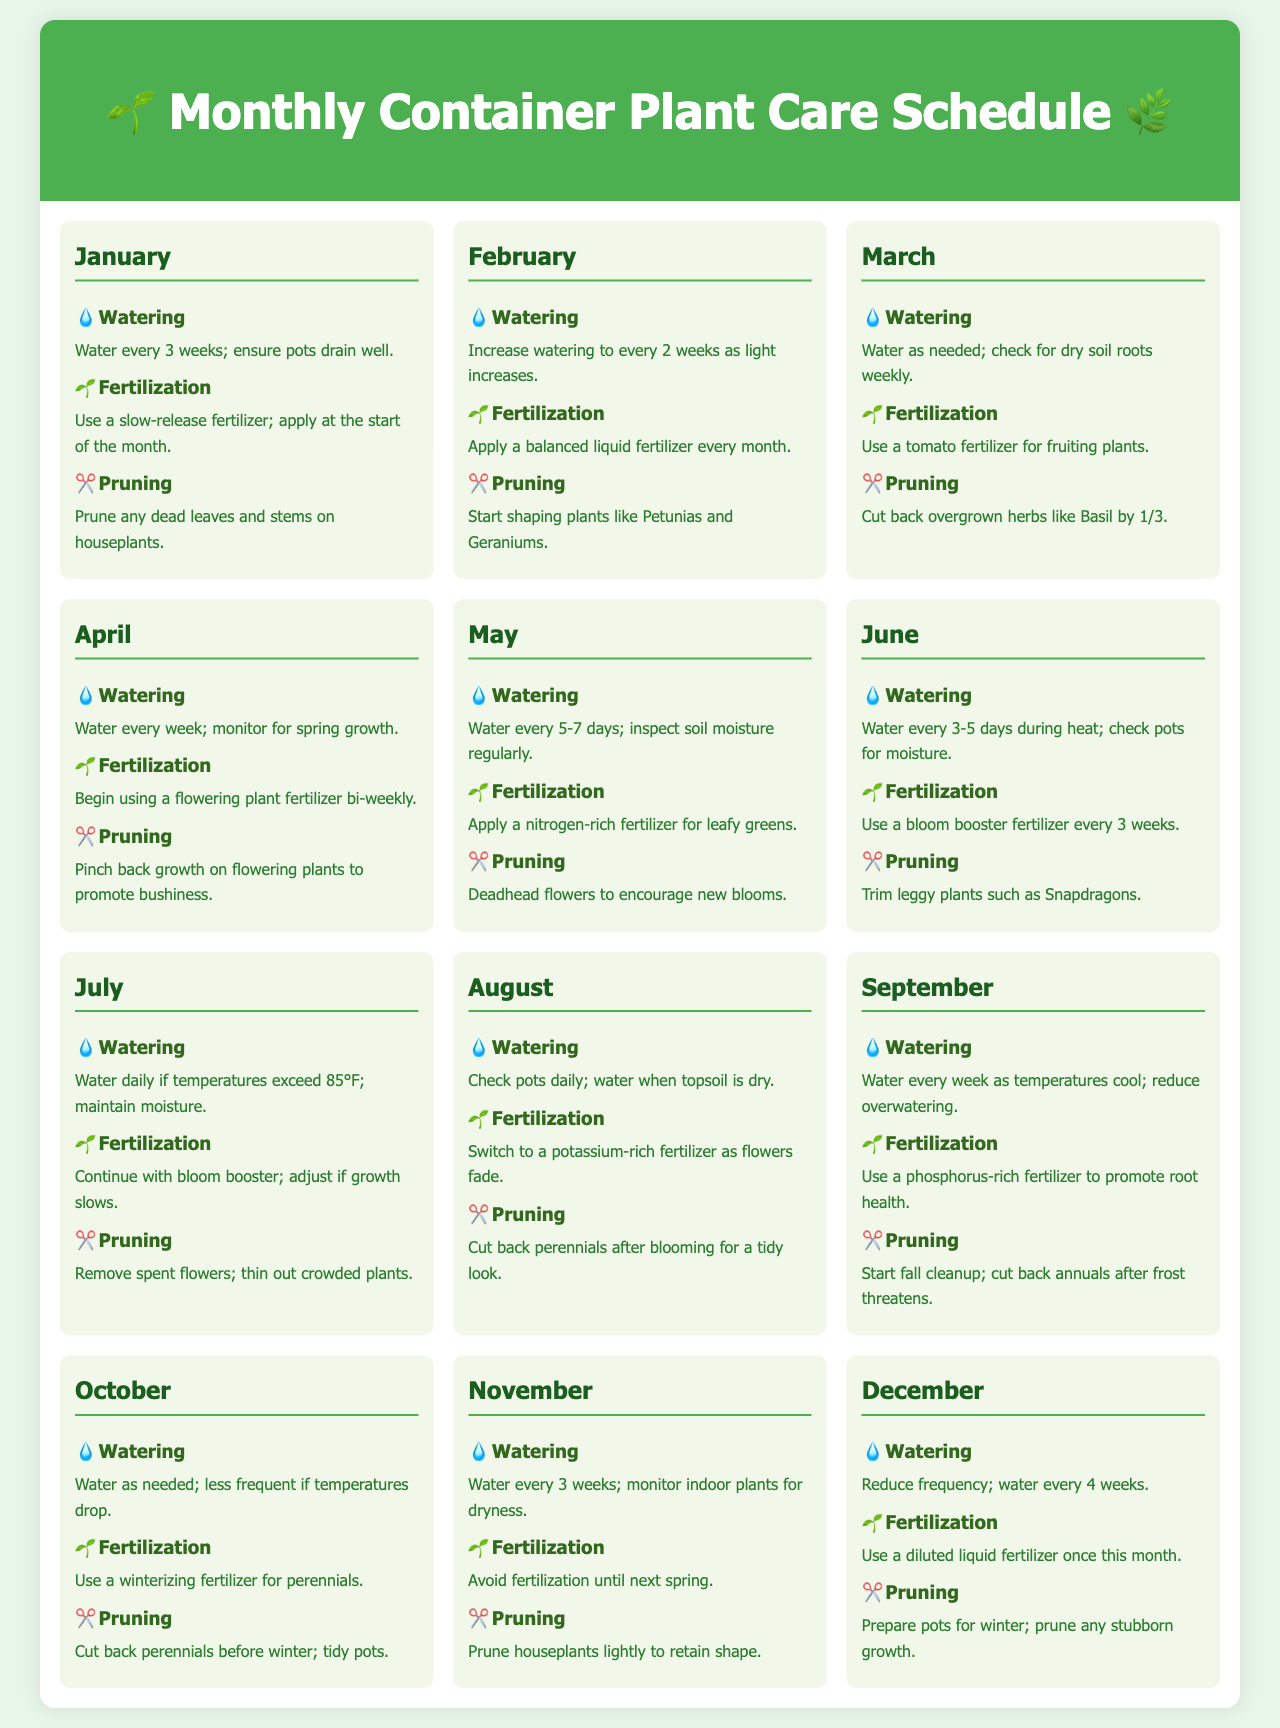what is the watering frequency for January? In January, watering should be every 3 weeks; ensure pots drain well.
Answer: every 3 weeks which fertilizer is recommended in March? For March, it is recommended to use a tomato fertilizer for fruiting plants.
Answer: tomato fertilizer how often should you prune plants in July? In July, the guideline is to remove spent flowers and thin out crowded plants.
Answer: remove spent flowers what type of fertilizer should be used in September? A phosphorus-rich fertilizer is recommended to promote root health in September.
Answer: phosphorus-rich fertilizer how often should plants be watered in June? In June, plants should be watered every 3-5 days during heat.
Answer: every 3-5 days what should be done to perennials after blooming in August? After blooming in August, perennials should be cut back for a tidy look.
Answer: cut back perennials which month requires monitoring indoor plants for dryness? In November, it is necessary to monitor indoor plants for dryness.
Answer: November which month suggests using a winterizing fertilizer? In October, the suggestion is to use a winterizing fertilizer for perennials.
Answer: October 